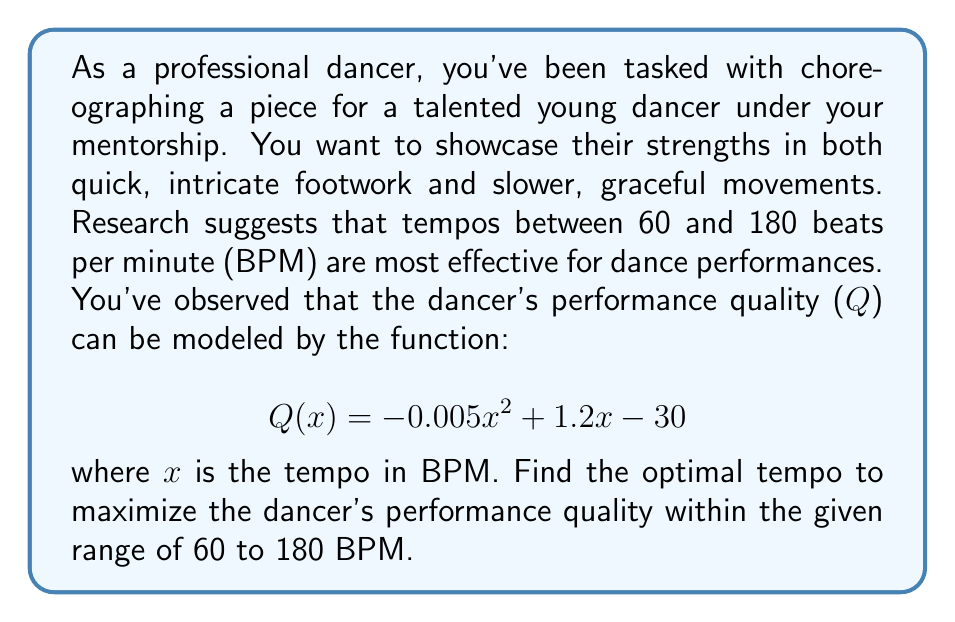Help me with this question. To find the optimal tempo, we need to maximize the quadratic function $Q(x)$ within the given range. Let's approach this step-by-step:

1) The function $Q(x) = -0.005x^2 + 1.2x - 30$ is a quadratic function with a negative leading coefficient, so it opens downward and has a maximum value.

2) To find the maximum, we can calculate the vertex of the parabola. The x-coordinate of the vertex will give us the optimal tempo.

3) For a quadratic function in the form $ax^2 + bx + c$, the x-coordinate of the vertex is given by $x = -\frac{b}{2a}$.

4) In our case, $a = -0.005$, $b = 1.2$, and $c = -30$.

5) Substituting these values:

   $$x = -\frac{1.2}{2(-0.005)} = -\frac{1.2}{-0.01} = 120$$

6) The vertex occurs at $x = 120$ BPM.

7) We need to verify if this value is within our given range of 60 to 180 BPM.

8) Since 120 is indeed between 60 and 180, this is our optimal tempo.

9) To calculate the maximum quality, we can substitute $x = 120$ into our original function:

   $$Q(120) = -0.005(120)^2 + 1.2(120) - 30$$
   $$= -72 + 144 - 30 = 42$$

Therefore, the optimal tempo is 120 BPM, which will result in a maximum performance quality of 42.
Answer: The optimal tempo is 120 BPM. 